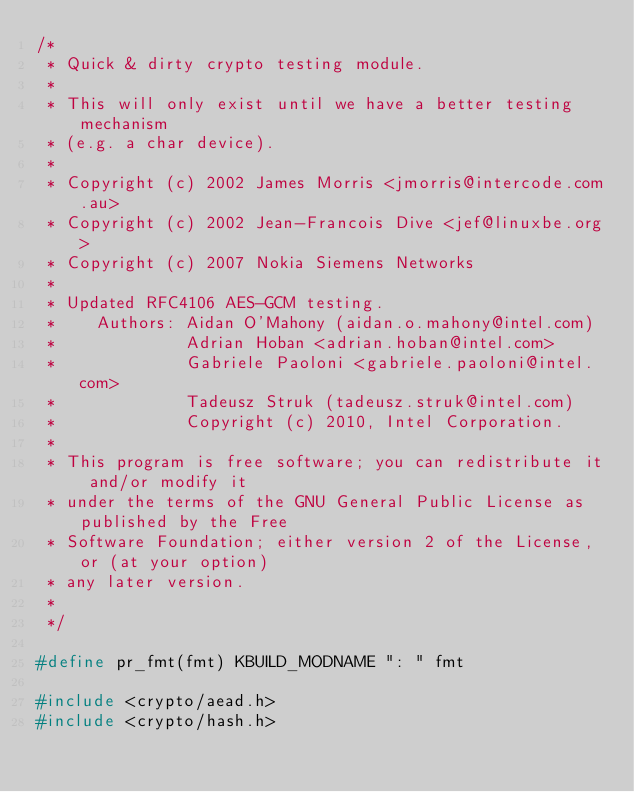Convert code to text. <code><loc_0><loc_0><loc_500><loc_500><_C_>/*
 * Quick & dirty crypto testing module.
 *
 * This will only exist until we have a better testing mechanism
 * (e.g. a char device).
 *
 * Copyright (c) 2002 James Morris <jmorris@intercode.com.au>
 * Copyright (c) 2002 Jean-Francois Dive <jef@linuxbe.org>
 * Copyright (c) 2007 Nokia Siemens Networks
 *
 * Updated RFC4106 AES-GCM testing.
 *    Authors: Aidan O'Mahony (aidan.o.mahony@intel.com)
 *             Adrian Hoban <adrian.hoban@intel.com>
 *             Gabriele Paoloni <gabriele.paoloni@intel.com>
 *             Tadeusz Struk (tadeusz.struk@intel.com)
 *             Copyright (c) 2010, Intel Corporation.
 *
 * This program is free software; you can redistribute it and/or modify it
 * under the terms of the GNU General Public License as published by the Free
 * Software Foundation; either version 2 of the License, or (at your option)
 * any later version.
 *
 */

#define pr_fmt(fmt) KBUILD_MODNAME ": " fmt

#include <crypto/aead.h>
#include <crypto/hash.h></code> 